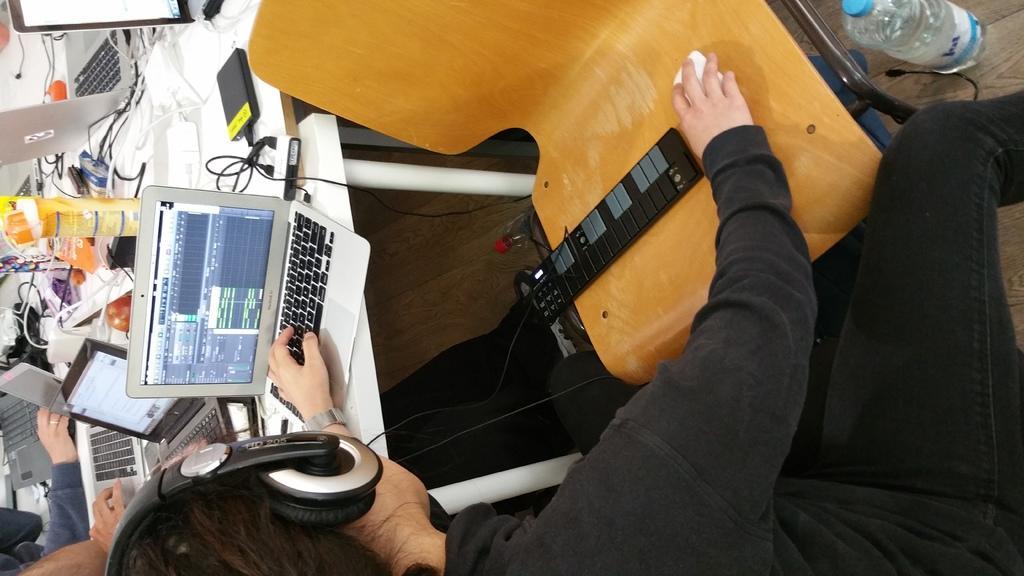In one or two sentences, can you explain what this image depicts? In this picture we can see laptops, wires and some objects on the table. We can see a few objects on the chair. There is a person wearing a headset and holding an object visible on a chair. We can see the bottles and the hands of a few people. 